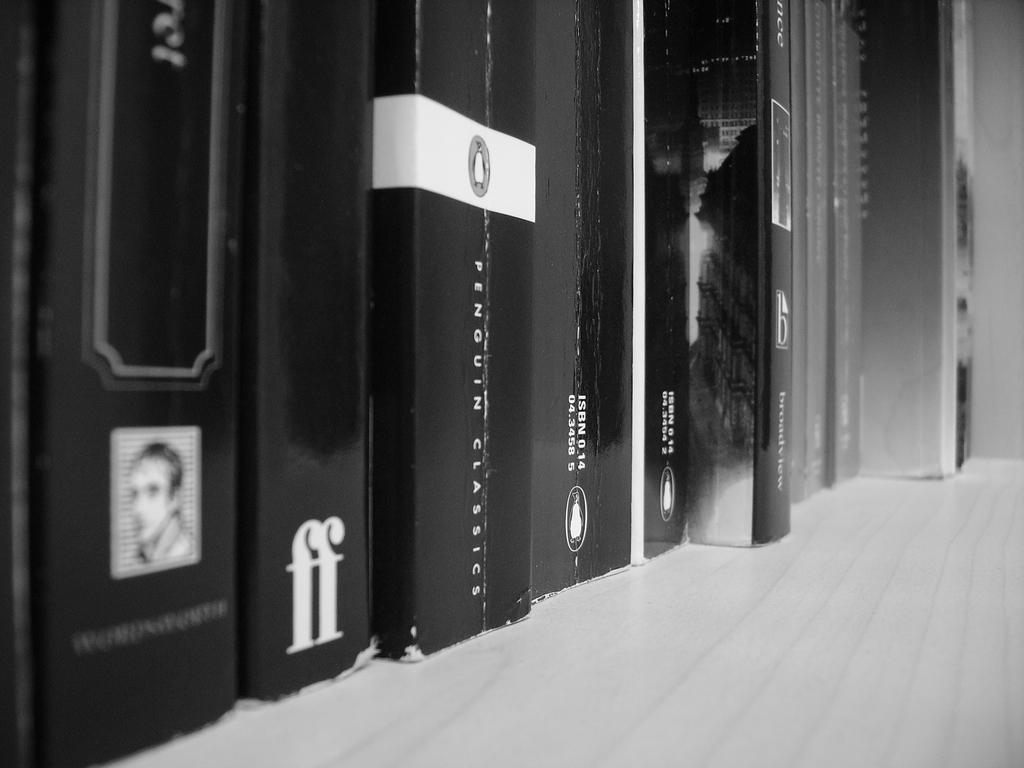What is the color scheme of the image? The image is black and white. What objects can be seen in the image? There are books in the image. How are the books arranged in the image? The books are in order. What type of flight is depicted in the image? There is no flight depicted in the image; it is a black and white image of books in order. What emotion is the vessel expressing in the image? There is no vessel present in the image, and therefore no emotion can be attributed to it. 